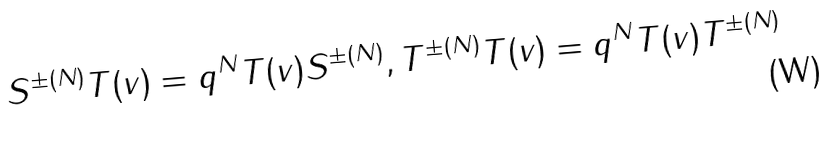<formula> <loc_0><loc_0><loc_500><loc_500>S ^ { \pm ( N ) } T ( v ) = q ^ { N } T ( v ) S ^ { \pm ( N ) } , T ^ { \pm ( N ) } T ( v ) = q ^ { N } T ( v ) T ^ { \pm ( N ) }</formula> 